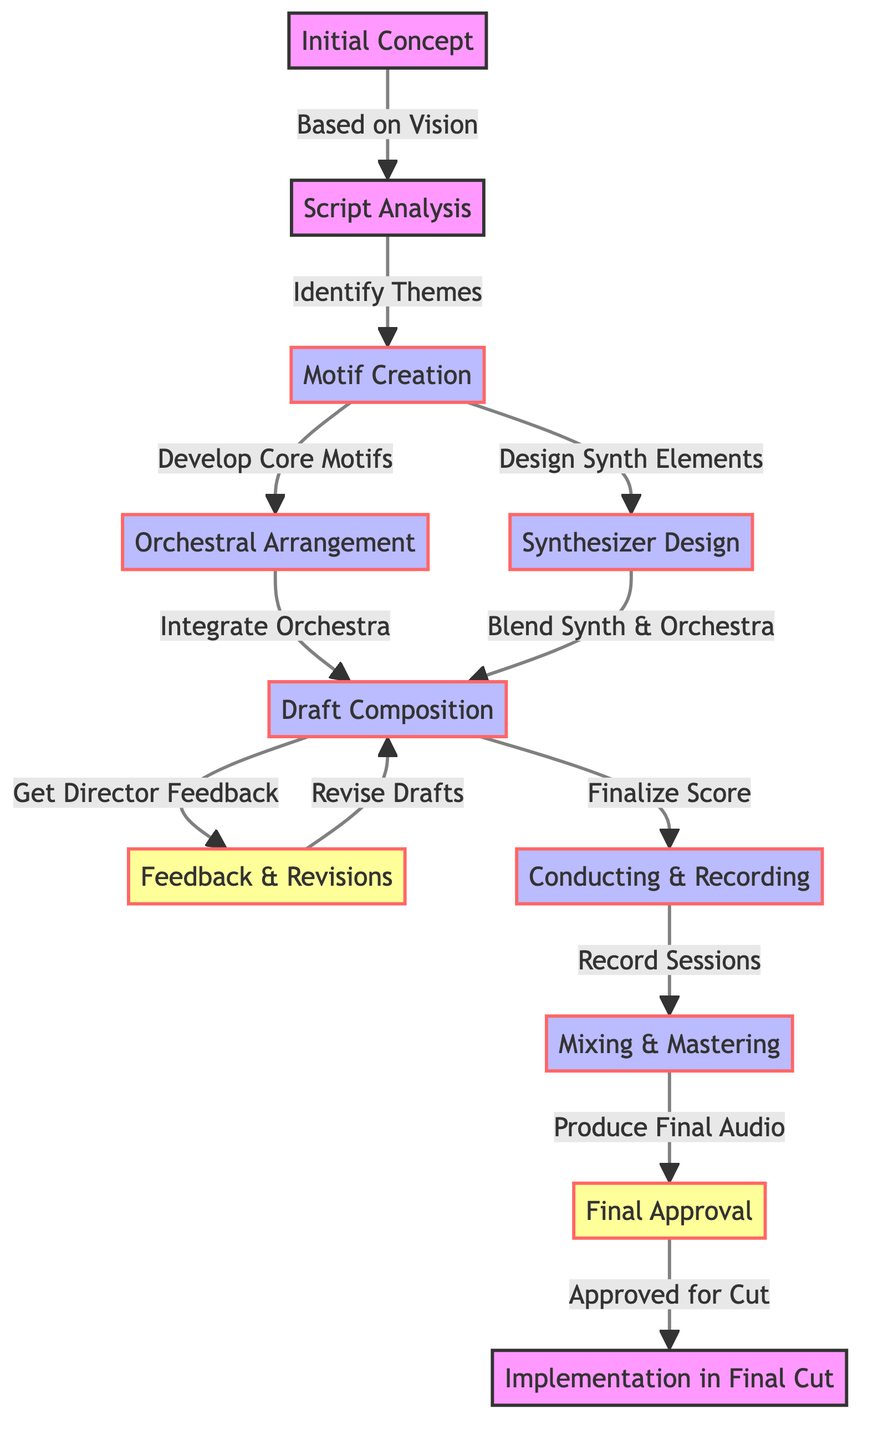What is the first step in the film score composition workflow? The first node in the diagram is "Initial Concept," which indicates the starting point of the workflow.
Answer: Initial Concept How many nodes are present in the diagram? By counting the individual elements labeled as nodes in the diagram, we find there are 11 nodes total.
Answer: 11 Which two nodes are connected by the label "Develop Core Motifs"? The edges show that "Motif Creation" is connected to "Orchestral Arrangement," and the label on that edge is "Develop Core Motifs."
Answer: Orchestral Arrangement and Motif Creation What action follows "Draft Composition" in the workflow? Following "Draft Composition," the next action in the workflow is "Feedback & Revisions," as indicated by the edge connecting these two nodes.
Answer: Feedback & Revisions How does "Motif Creation" relate to both "Orchestral Arrangement" and "Synthesizer Design"? "Motif Creation" has edges going to both "Orchestral Arrangement" and "Synthesizer Design," indicating that motifs influence both orchestral and synth elements.
Answer: Develop Core Motifs and Design Synth Elements What is the final step before implementation in the final cut? According to the diagram, the final step before "Implementation in Final Cut" is "Final Approval", which precedes it directly in the workflow.
Answer: Final Approval In the workflow, what step must occur after "Conducting & Recording"? The step following "Conducting & Recording" according to the diagram is "Mixing & Mastering," as shown by the connecting edge.
Answer: Mixing & Mastering What is the label indicating the connection between "Feedback & Revisions" and "Draft Composition"? The label on the edge connecting these two nodes is "Revise Drafts," which signifies the nature of that connection.
Answer: Revise Drafts How many edges connect the nodes in the diagram? By counting the connections (edges) between nodes, we find that there are 10 edges in total.
Answer: 10 